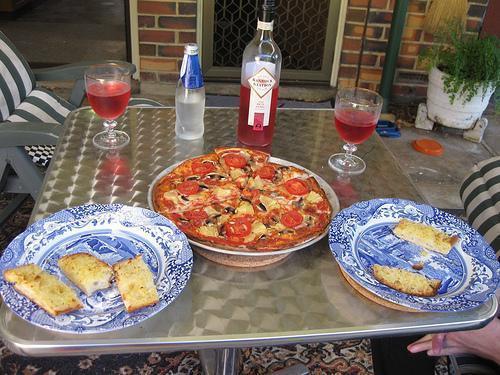How many dining tables can you see?
Give a very brief answer. 1. How many people can you see?
Give a very brief answer. 1. How many wine glasses can be seen?
Give a very brief answer. 2. How many pizzas are there?
Give a very brief answer. 2. How many bottles are there?
Give a very brief answer. 2. 